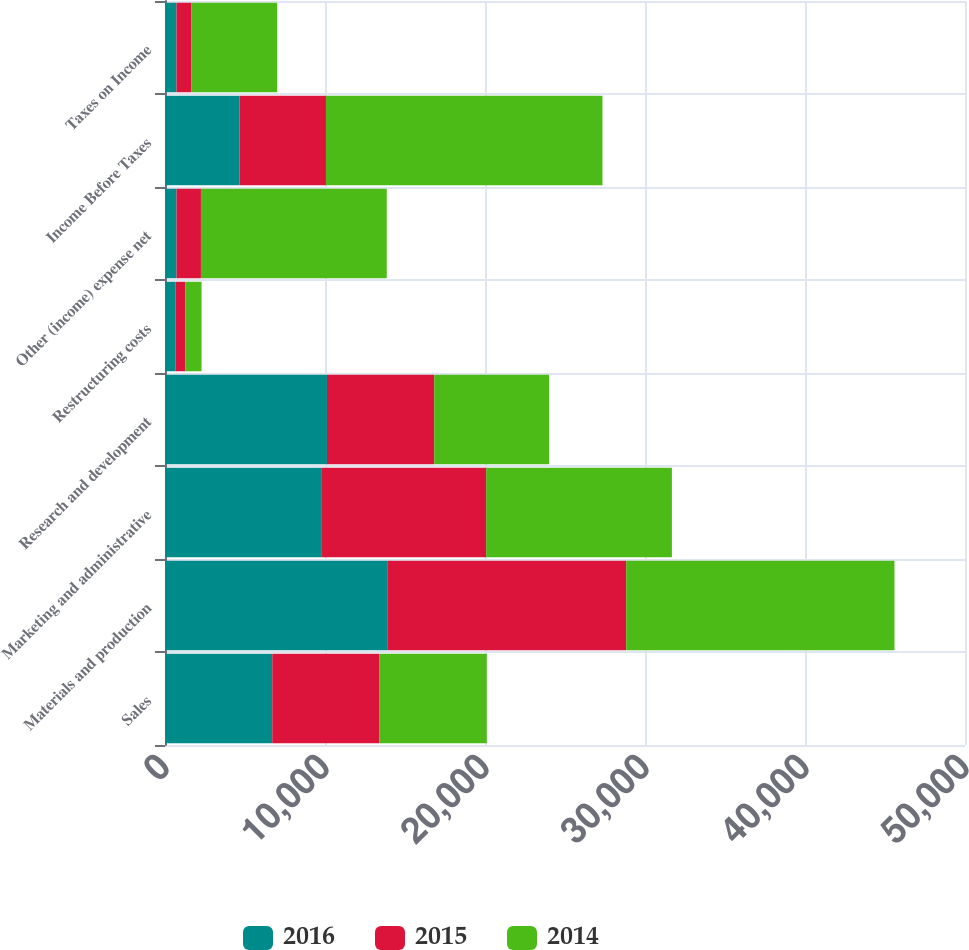<chart> <loc_0><loc_0><loc_500><loc_500><stacked_bar_chart><ecel><fcel>Sales<fcel>Materials and production<fcel>Marketing and administrative<fcel>Research and development<fcel>Restructuring costs<fcel>Other (income) expense net<fcel>Income Before Taxes<fcel>Taxes on Income<nl><fcel>2016<fcel>6704<fcel>13891<fcel>9762<fcel>10124<fcel>651<fcel>720<fcel>4659<fcel>718<nl><fcel>2015<fcel>6704<fcel>14934<fcel>10313<fcel>6704<fcel>619<fcel>1527<fcel>5401<fcel>942<nl><fcel>2014<fcel>6704<fcel>16768<fcel>11606<fcel>7180<fcel>1013<fcel>11613<fcel>17283<fcel>5349<nl></chart> 